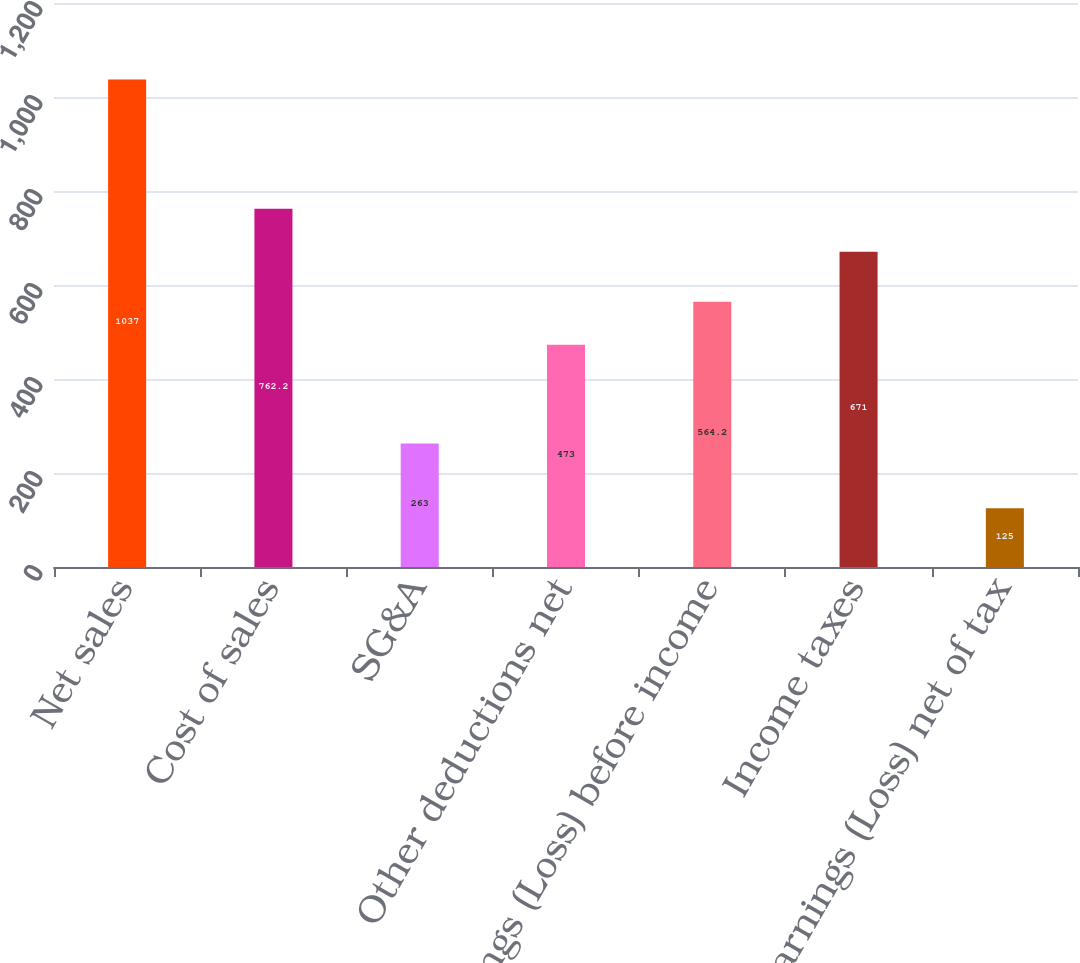<chart> <loc_0><loc_0><loc_500><loc_500><bar_chart><fcel>Net sales<fcel>Cost of sales<fcel>SG&A<fcel>Other deductions net<fcel>Earnings (Loss) before income<fcel>Income taxes<fcel>Earnings (Loss) net of tax<nl><fcel>1037<fcel>762.2<fcel>263<fcel>473<fcel>564.2<fcel>671<fcel>125<nl></chart> 